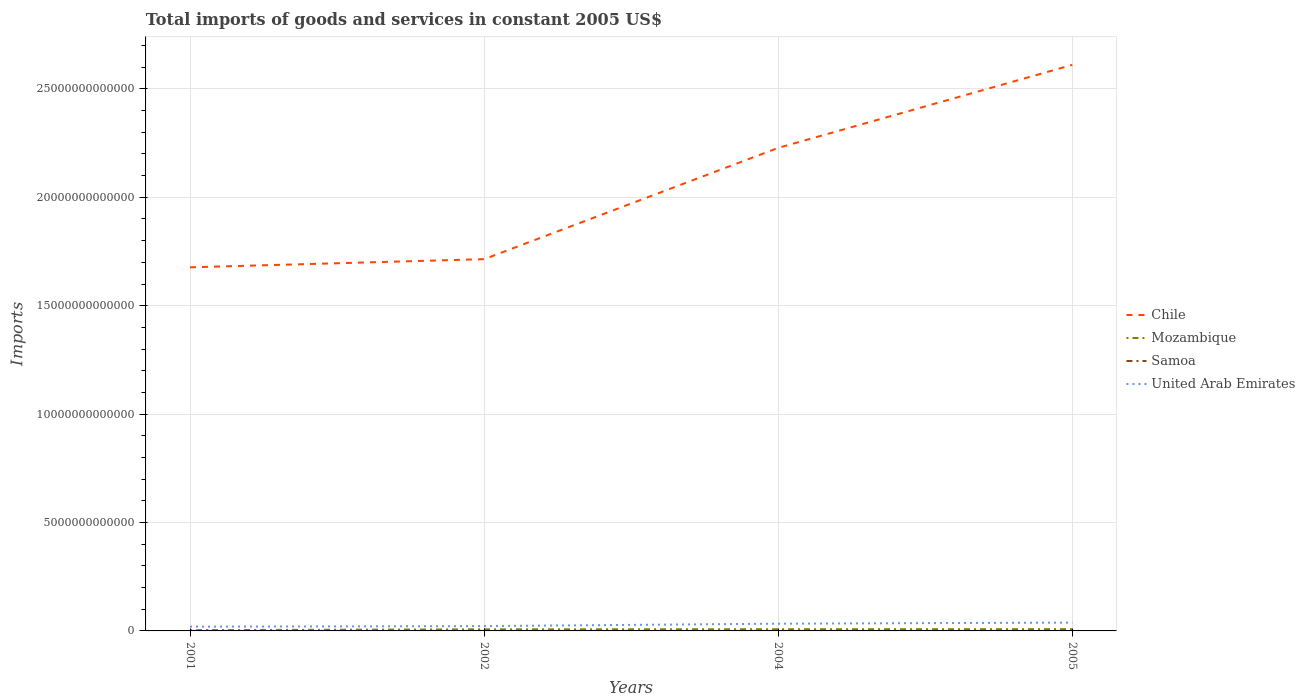Does the line corresponding to Chile intersect with the line corresponding to Mozambique?
Offer a terse response. No. Is the number of lines equal to the number of legend labels?
Your answer should be very brief. Yes. Across all years, what is the maximum total imports of goods and services in Mozambique?
Offer a terse response. 3.62e+1. In which year was the total imports of goods and services in Chile maximum?
Keep it short and to the point. 2001. What is the total total imports of goods and services in Mozambique in the graph?
Your answer should be compact. -4.72e+09. What is the difference between the highest and the second highest total imports of goods and services in Samoa?
Give a very brief answer. 1.83e+08. What is the difference between the highest and the lowest total imports of goods and services in United Arab Emirates?
Offer a very short reply. 2. Is the total imports of goods and services in United Arab Emirates strictly greater than the total imports of goods and services in Chile over the years?
Give a very brief answer. Yes. How many lines are there?
Offer a very short reply. 4. What is the difference between two consecutive major ticks on the Y-axis?
Provide a short and direct response. 5.00e+12. Are the values on the major ticks of Y-axis written in scientific E-notation?
Your response must be concise. No. How are the legend labels stacked?
Keep it short and to the point. Vertical. What is the title of the graph?
Ensure brevity in your answer.  Total imports of goods and services in constant 2005 US$. What is the label or title of the X-axis?
Offer a terse response. Years. What is the label or title of the Y-axis?
Keep it short and to the point. Imports. What is the Imports in Chile in 2001?
Make the answer very short. 1.68e+13. What is the Imports in Mozambique in 2001?
Provide a succinct answer. 3.62e+1. What is the Imports of Samoa in 2001?
Provide a succinct answer. 6.52e+08. What is the Imports of United Arab Emirates in 2001?
Your answer should be very brief. 1.97e+11. What is the Imports of Chile in 2002?
Keep it short and to the point. 1.71e+13. What is the Imports in Mozambique in 2002?
Give a very brief answer. 7.41e+1. What is the Imports in Samoa in 2002?
Your answer should be very brief. 6.73e+08. What is the Imports of United Arab Emirates in 2002?
Your answer should be very brief. 2.22e+11. What is the Imports of Chile in 2004?
Your answer should be compact. 2.23e+13. What is the Imports in Mozambique in 2004?
Make the answer very short. 7.88e+1. What is the Imports in Samoa in 2004?
Ensure brevity in your answer.  4.91e+08. What is the Imports of United Arab Emirates in 2004?
Offer a very short reply. 3.34e+11. What is the Imports in Chile in 2005?
Your response must be concise. 2.61e+13. What is the Imports of Mozambique in 2005?
Your answer should be compact. 8.32e+1. What is the Imports in Samoa in 2005?
Give a very brief answer. 5.65e+08. What is the Imports of United Arab Emirates in 2005?
Your answer should be compact. 3.84e+11. Across all years, what is the maximum Imports in Chile?
Your answer should be compact. 2.61e+13. Across all years, what is the maximum Imports in Mozambique?
Provide a short and direct response. 8.32e+1. Across all years, what is the maximum Imports in Samoa?
Offer a terse response. 6.73e+08. Across all years, what is the maximum Imports in United Arab Emirates?
Ensure brevity in your answer.  3.84e+11. Across all years, what is the minimum Imports of Chile?
Ensure brevity in your answer.  1.68e+13. Across all years, what is the minimum Imports in Mozambique?
Give a very brief answer. 3.62e+1. Across all years, what is the minimum Imports of Samoa?
Your answer should be very brief. 4.91e+08. Across all years, what is the minimum Imports of United Arab Emirates?
Make the answer very short. 1.97e+11. What is the total Imports of Chile in the graph?
Provide a short and direct response. 8.23e+13. What is the total Imports of Mozambique in the graph?
Keep it short and to the point. 2.72e+11. What is the total Imports of Samoa in the graph?
Your response must be concise. 2.38e+09. What is the total Imports of United Arab Emirates in the graph?
Give a very brief answer. 1.14e+12. What is the difference between the Imports in Chile in 2001 and that in 2002?
Your response must be concise. -3.78e+11. What is the difference between the Imports in Mozambique in 2001 and that in 2002?
Your answer should be very brief. -3.79e+1. What is the difference between the Imports of Samoa in 2001 and that in 2002?
Offer a terse response. -2.11e+07. What is the difference between the Imports of United Arab Emirates in 2001 and that in 2002?
Provide a short and direct response. -2.54e+1. What is the difference between the Imports of Chile in 2001 and that in 2004?
Give a very brief answer. -5.51e+12. What is the difference between the Imports of Mozambique in 2001 and that in 2004?
Keep it short and to the point. -4.26e+1. What is the difference between the Imports in Samoa in 2001 and that in 2004?
Ensure brevity in your answer.  1.61e+08. What is the difference between the Imports in United Arab Emirates in 2001 and that in 2004?
Offer a terse response. -1.37e+11. What is the difference between the Imports of Chile in 2001 and that in 2005?
Your answer should be very brief. -9.34e+12. What is the difference between the Imports of Mozambique in 2001 and that in 2005?
Provide a short and direct response. -4.69e+1. What is the difference between the Imports of Samoa in 2001 and that in 2005?
Offer a terse response. 8.75e+07. What is the difference between the Imports in United Arab Emirates in 2001 and that in 2005?
Provide a succinct answer. -1.87e+11. What is the difference between the Imports of Chile in 2002 and that in 2004?
Offer a terse response. -5.13e+12. What is the difference between the Imports in Mozambique in 2002 and that in 2004?
Your answer should be compact. -4.72e+09. What is the difference between the Imports of Samoa in 2002 and that in 2004?
Your answer should be compact. 1.83e+08. What is the difference between the Imports in United Arab Emirates in 2002 and that in 2004?
Give a very brief answer. -1.12e+11. What is the difference between the Imports in Chile in 2002 and that in 2005?
Your answer should be very brief. -8.96e+12. What is the difference between the Imports in Mozambique in 2002 and that in 2005?
Provide a succinct answer. -9.03e+09. What is the difference between the Imports of Samoa in 2002 and that in 2005?
Provide a succinct answer. 1.09e+08. What is the difference between the Imports of United Arab Emirates in 2002 and that in 2005?
Your answer should be very brief. -1.62e+11. What is the difference between the Imports of Chile in 2004 and that in 2005?
Keep it short and to the point. -3.83e+12. What is the difference between the Imports in Mozambique in 2004 and that in 2005?
Your response must be concise. -4.32e+09. What is the difference between the Imports of Samoa in 2004 and that in 2005?
Your answer should be compact. -7.40e+07. What is the difference between the Imports in United Arab Emirates in 2004 and that in 2005?
Give a very brief answer. -4.99e+1. What is the difference between the Imports of Chile in 2001 and the Imports of Mozambique in 2002?
Give a very brief answer. 1.67e+13. What is the difference between the Imports of Chile in 2001 and the Imports of Samoa in 2002?
Give a very brief answer. 1.68e+13. What is the difference between the Imports in Chile in 2001 and the Imports in United Arab Emirates in 2002?
Ensure brevity in your answer.  1.65e+13. What is the difference between the Imports of Mozambique in 2001 and the Imports of Samoa in 2002?
Provide a short and direct response. 3.56e+1. What is the difference between the Imports of Mozambique in 2001 and the Imports of United Arab Emirates in 2002?
Make the answer very short. -1.86e+11. What is the difference between the Imports in Samoa in 2001 and the Imports in United Arab Emirates in 2002?
Ensure brevity in your answer.  -2.21e+11. What is the difference between the Imports in Chile in 2001 and the Imports in Mozambique in 2004?
Your answer should be very brief. 1.67e+13. What is the difference between the Imports in Chile in 2001 and the Imports in Samoa in 2004?
Provide a short and direct response. 1.68e+13. What is the difference between the Imports of Chile in 2001 and the Imports of United Arab Emirates in 2004?
Keep it short and to the point. 1.64e+13. What is the difference between the Imports of Mozambique in 2001 and the Imports of Samoa in 2004?
Make the answer very short. 3.57e+1. What is the difference between the Imports in Mozambique in 2001 and the Imports in United Arab Emirates in 2004?
Provide a succinct answer. -2.98e+11. What is the difference between the Imports in Samoa in 2001 and the Imports in United Arab Emirates in 2004?
Ensure brevity in your answer.  -3.33e+11. What is the difference between the Imports of Chile in 2001 and the Imports of Mozambique in 2005?
Provide a short and direct response. 1.67e+13. What is the difference between the Imports of Chile in 2001 and the Imports of Samoa in 2005?
Provide a succinct answer. 1.68e+13. What is the difference between the Imports of Chile in 2001 and the Imports of United Arab Emirates in 2005?
Keep it short and to the point. 1.64e+13. What is the difference between the Imports in Mozambique in 2001 and the Imports in Samoa in 2005?
Give a very brief answer. 3.57e+1. What is the difference between the Imports in Mozambique in 2001 and the Imports in United Arab Emirates in 2005?
Provide a succinct answer. -3.48e+11. What is the difference between the Imports of Samoa in 2001 and the Imports of United Arab Emirates in 2005?
Provide a short and direct response. -3.83e+11. What is the difference between the Imports in Chile in 2002 and the Imports in Mozambique in 2004?
Your answer should be very brief. 1.71e+13. What is the difference between the Imports in Chile in 2002 and the Imports in Samoa in 2004?
Keep it short and to the point. 1.71e+13. What is the difference between the Imports in Chile in 2002 and the Imports in United Arab Emirates in 2004?
Keep it short and to the point. 1.68e+13. What is the difference between the Imports in Mozambique in 2002 and the Imports in Samoa in 2004?
Provide a short and direct response. 7.36e+1. What is the difference between the Imports in Mozambique in 2002 and the Imports in United Arab Emirates in 2004?
Provide a short and direct response. -2.60e+11. What is the difference between the Imports of Samoa in 2002 and the Imports of United Arab Emirates in 2004?
Provide a succinct answer. -3.33e+11. What is the difference between the Imports in Chile in 2002 and the Imports in Mozambique in 2005?
Your answer should be very brief. 1.71e+13. What is the difference between the Imports in Chile in 2002 and the Imports in Samoa in 2005?
Your answer should be very brief. 1.71e+13. What is the difference between the Imports in Chile in 2002 and the Imports in United Arab Emirates in 2005?
Your response must be concise. 1.68e+13. What is the difference between the Imports of Mozambique in 2002 and the Imports of Samoa in 2005?
Your answer should be very brief. 7.36e+1. What is the difference between the Imports of Mozambique in 2002 and the Imports of United Arab Emirates in 2005?
Make the answer very short. -3.10e+11. What is the difference between the Imports in Samoa in 2002 and the Imports in United Arab Emirates in 2005?
Your answer should be compact. -3.83e+11. What is the difference between the Imports in Chile in 2004 and the Imports in Mozambique in 2005?
Your answer should be very brief. 2.22e+13. What is the difference between the Imports of Chile in 2004 and the Imports of Samoa in 2005?
Ensure brevity in your answer.  2.23e+13. What is the difference between the Imports in Chile in 2004 and the Imports in United Arab Emirates in 2005?
Provide a succinct answer. 2.19e+13. What is the difference between the Imports of Mozambique in 2004 and the Imports of Samoa in 2005?
Keep it short and to the point. 7.83e+1. What is the difference between the Imports of Mozambique in 2004 and the Imports of United Arab Emirates in 2005?
Offer a very short reply. -3.05e+11. What is the difference between the Imports in Samoa in 2004 and the Imports in United Arab Emirates in 2005?
Offer a very short reply. -3.83e+11. What is the average Imports of Chile per year?
Your response must be concise. 2.06e+13. What is the average Imports of Mozambique per year?
Keep it short and to the point. 6.81e+1. What is the average Imports in Samoa per year?
Offer a terse response. 5.95e+08. What is the average Imports in United Arab Emirates per year?
Give a very brief answer. 2.84e+11. In the year 2001, what is the difference between the Imports of Chile and Imports of Mozambique?
Keep it short and to the point. 1.67e+13. In the year 2001, what is the difference between the Imports of Chile and Imports of Samoa?
Provide a short and direct response. 1.68e+13. In the year 2001, what is the difference between the Imports of Chile and Imports of United Arab Emirates?
Make the answer very short. 1.66e+13. In the year 2001, what is the difference between the Imports in Mozambique and Imports in Samoa?
Provide a succinct answer. 3.56e+1. In the year 2001, what is the difference between the Imports in Mozambique and Imports in United Arab Emirates?
Provide a succinct answer. -1.60e+11. In the year 2001, what is the difference between the Imports of Samoa and Imports of United Arab Emirates?
Offer a very short reply. -1.96e+11. In the year 2002, what is the difference between the Imports in Chile and Imports in Mozambique?
Make the answer very short. 1.71e+13. In the year 2002, what is the difference between the Imports of Chile and Imports of Samoa?
Give a very brief answer. 1.71e+13. In the year 2002, what is the difference between the Imports in Chile and Imports in United Arab Emirates?
Your answer should be very brief. 1.69e+13. In the year 2002, what is the difference between the Imports in Mozambique and Imports in Samoa?
Provide a succinct answer. 7.35e+1. In the year 2002, what is the difference between the Imports of Mozambique and Imports of United Arab Emirates?
Offer a terse response. -1.48e+11. In the year 2002, what is the difference between the Imports in Samoa and Imports in United Arab Emirates?
Keep it short and to the point. -2.21e+11. In the year 2004, what is the difference between the Imports in Chile and Imports in Mozambique?
Make the answer very short. 2.22e+13. In the year 2004, what is the difference between the Imports in Chile and Imports in Samoa?
Your answer should be very brief. 2.23e+13. In the year 2004, what is the difference between the Imports of Chile and Imports of United Arab Emirates?
Your response must be concise. 2.19e+13. In the year 2004, what is the difference between the Imports in Mozambique and Imports in Samoa?
Your answer should be compact. 7.84e+1. In the year 2004, what is the difference between the Imports of Mozambique and Imports of United Arab Emirates?
Your response must be concise. -2.55e+11. In the year 2004, what is the difference between the Imports of Samoa and Imports of United Arab Emirates?
Provide a succinct answer. -3.34e+11. In the year 2005, what is the difference between the Imports in Chile and Imports in Mozambique?
Your response must be concise. 2.60e+13. In the year 2005, what is the difference between the Imports of Chile and Imports of Samoa?
Your response must be concise. 2.61e+13. In the year 2005, what is the difference between the Imports of Chile and Imports of United Arab Emirates?
Provide a short and direct response. 2.57e+13. In the year 2005, what is the difference between the Imports of Mozambique and Imports of Samoa?
Your response must be concise. 8.26e+1. In the year 2005, what is the difference between the Imports in Mozambique and Imports in United Arab Emirates?
Your answer should be very brief. -3.01e+11. In the year 2005, what is the difference between the Imports of Samoa and Imports of United Arab Emirates?
Give a very brief answer. -3.83e+11. What is the ratio of the Imports in Chile in 2001 to that in 2002?
Offer a very short reply. 0.98. What is the ratio of the Imports of Mozambique in 2001 to that in 2002?
Provide a short and direct response. 0.49. What is the ratio of the Imports of Samoa in 2001 to that in 2002?
Offer a terse response. 0.97. What is the ratio of the Imports of United Arab Emirates in 2001 to that in 2002?
Make the answer very short. 0.89. What is the ratio of the Imports in Chile in 2001 to that in 2004?
Offer a terse response. 0.75. What is the ratio of the Imports in Mozambique in 2001 to that in 2004?
Keep it short and to the point. 0.46. What is the ratio of the Imports in Samoa in 2001 to that in 2004?
Your response must be concise. 1.33. What is the ratio of the Imports in United Arab Emirates in 2001 to that in 2004?
Offer a terse response. 0.59. What is the ratio of the Imports in Chile in 2001 to that in 2005?
Make the answer very short. 0.64. What is the ratio of the Imports in Mozambique in 2001 to that in 2005?
Offer a terse response. 0.44. What is the ratio of the Imports in Samoa in 2001 to that in 2005?
Your response must be concise. 1.15. What is the ratio of the Imports of United Arab Emirates in 2001 to that in 2005?
Offer a terse response. 0.51. What is the ratio of the Imports in Chile in 2002 to that in 2004?
Offer a terse response. 0.77. What is the ratio of the Imports in Mozambique in 2002 to that in 2004?
Your response must be concise. 0.94. What is the ratio of the Imports in Samoa in 2002 to that in 2004?
Provide a succinct answer. 1.37. What is the ratio of the Imports of United Arab Emirates in 2002 to that in 2004?
Offer a terse response. 0.66. What is the ratio of the Imports of Chile in 2002 to that in 2005?
Provide a short and direct response. 0.66. What is the ratio of the Imports in Mozambique in 2002 to that in 2005?
Your answer should be compact. 0.89. What is the ratio of the Imports in Samoa in 2002 to that in 2005?
Provide a succinct answer. 1.19. What is the ratio of the Imports of United Arab Emirates in 2002 to that in 2005?
Make the answer very short. 0.58. What is the ratio of the Imports of Chile in 2004 to that in 2005?
Give a very brief answer. 0.85. What is the ratio of the Imports of Mozambique in 2004 to that in 2005?
Ensure brevity in your answer.  0.95. What is the ratio of the Imports of Samoa in 2004 to that in 2005?
Keep it short and to the point. 0.87. What is the ratio of the Imports of United Arab Emirates in 2004 to that in 2005?
Ensure brevity in your answer.  0.87. What is the difference between the highest and the second highest Imports of Chile?
Your answer should be compact. 3.83e+12. What is the difference between the highest and the second highest Imports of Mozambique?
Give a very brief answer. 4.32e+09. What is the difference between the highest and the second highest Imports in Samoa?
Your answer should be compact. 2.11e+07. What is the difference between the highest and the second highest Imports of United Arab Emirates?
Make the answer very short. 4.99e+1. What is the difference between the highest and the lowest Imports of Chile?
Make the answer very short. 9.34e+12. What is the difference between the highest and the lowest Imports in Mozambique?
Make the answer very short. 4.69e+1. What is the difference between the highest and the lowest Imports of Samoa?
Keep it short and to the point. 1.83e+08. What is the difference between the highest and the lowest Imports of United Arab Emirates?
Your response must be concise. 1.87e+11. 